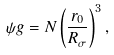Convert formula to latex. <formula><loc_0><loc_0><loc_500><loc_500>\psi g = N \left ( \frac { r _ { 0 } } { R _ { \sigma } } \right ) ^ { 3 } , \label H { e q \colon p h i s i g m a }</formula> 